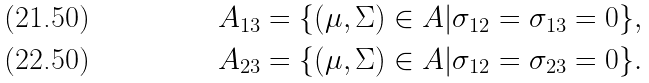Convert formula to latex. <formula><loc_0><loc_0><loc_500><loc_500>A _ { 1 3 } & = \{ ( \mu , \Sigma ) \in A | \sigma _ { 1 2 } = \sigma _ { 1 3 } = 0 \} , \\ A _ { 2 3 } & = \{ ( \mu , \Sigma ) \in A | \sigma _ { 1 2 } = \sigma _ { 2 3 } = 0 \} .</formula> 